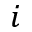<formula> <loc_0><loc_0><loc_500><loc_500>i</formula> 